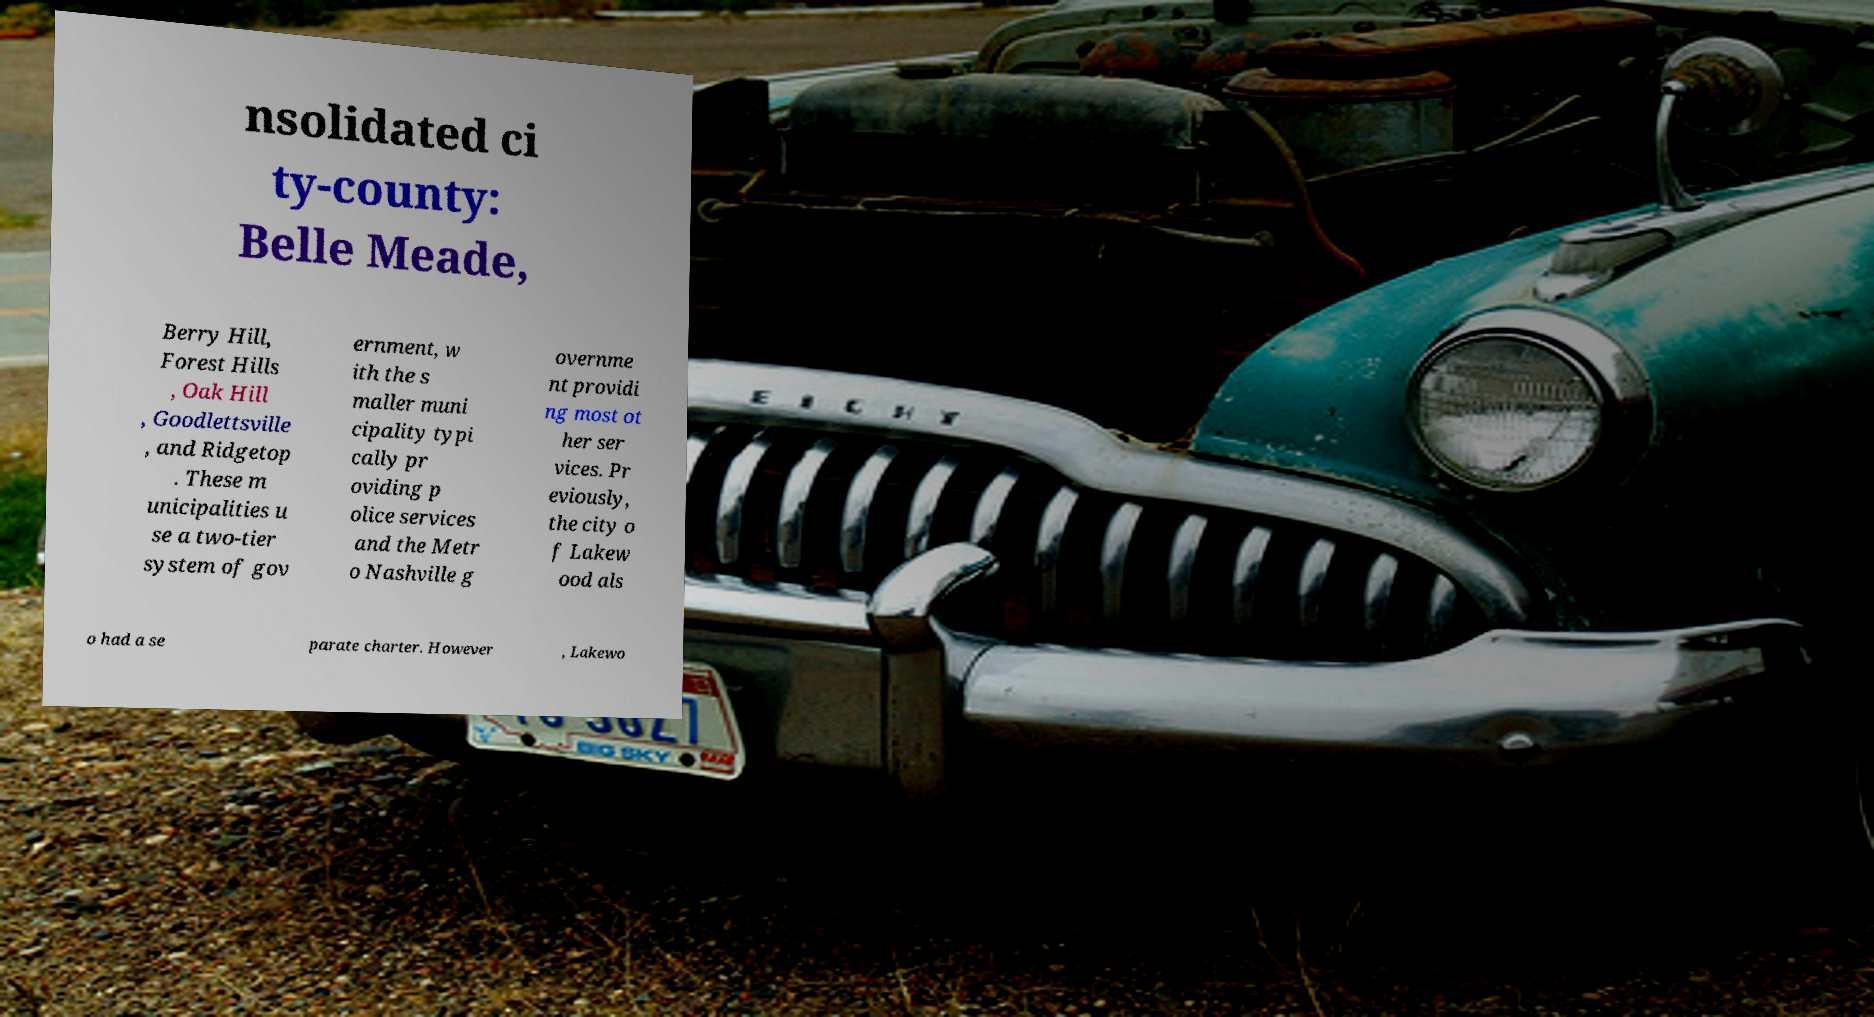What messages or text are displayed in this image? I need them in a readable, typed format. nsolidated ci ty-county: Belle Meade, Berry Hill, Forest Hills , Oak Hill , Goodlettsville , and Ridgetop . These m unicipalities u se a two-tier system of gov ernment, w ith the s maller muni cipality typi cally pr oviding p olice services and the Metr o Nashville g overnme nt providi ng most ot her ser vices. Pr eviously, the city o f Lakew ood als o had a se parate charter. However , Lakewo 